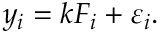<formula> <loc_0><loc_0><loc_500><loc_500>y _ { i } = k F _ { i } + \varepsilon _ { i } .</formula> 